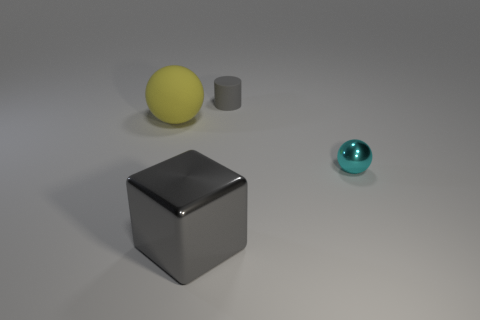Subtract all cyan balls. How many balls are left? 1 Add 2 small cyan shiny cylinders. How many objects exist? 6 Subtract all blocks. How many objects are left? 3 Add 2 big gray cubes. How many big gray cubes exist? 3 Subtract 0 blue cylinders. How many objects are left? 4 Subtract all cyan blocks. Subtract all brown cylinders. How many blocks are left? 1 Subtract all large balls. Subtract all large gray cubes. How many objects are left? 2 Add 1 cyan metallic spheres. How many cyan metallic spheres are left? 2 